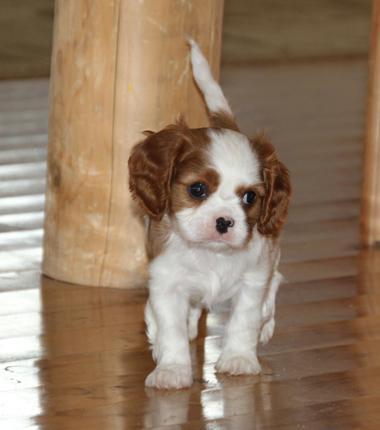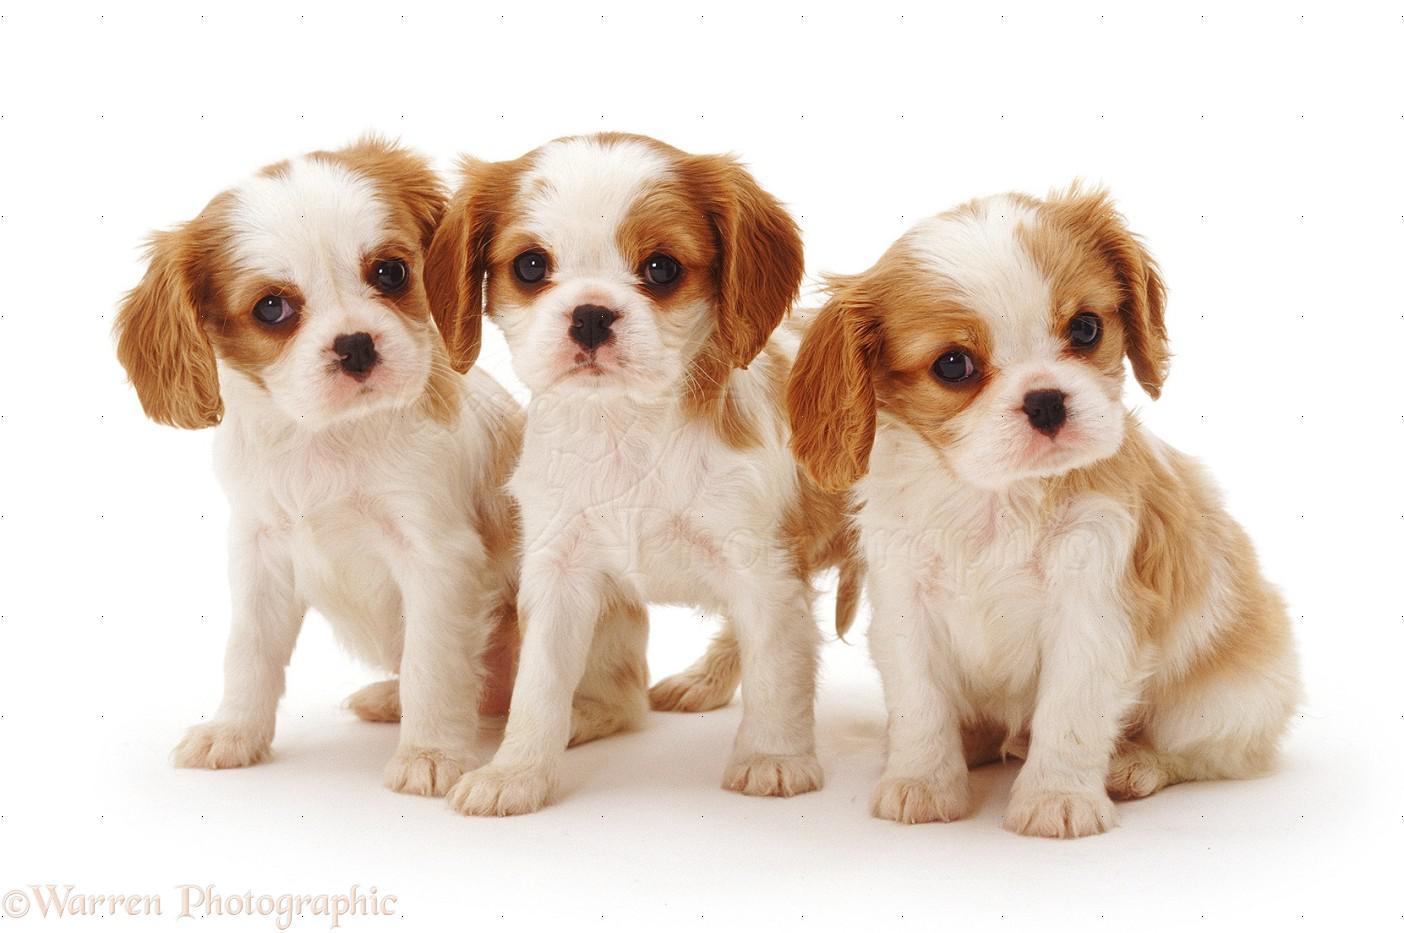The first image is the image on the left, the second image is the image on the right. Given the left and right images, does the statement "At least one dog is laying down." hold true? Answer yes or no. No. 